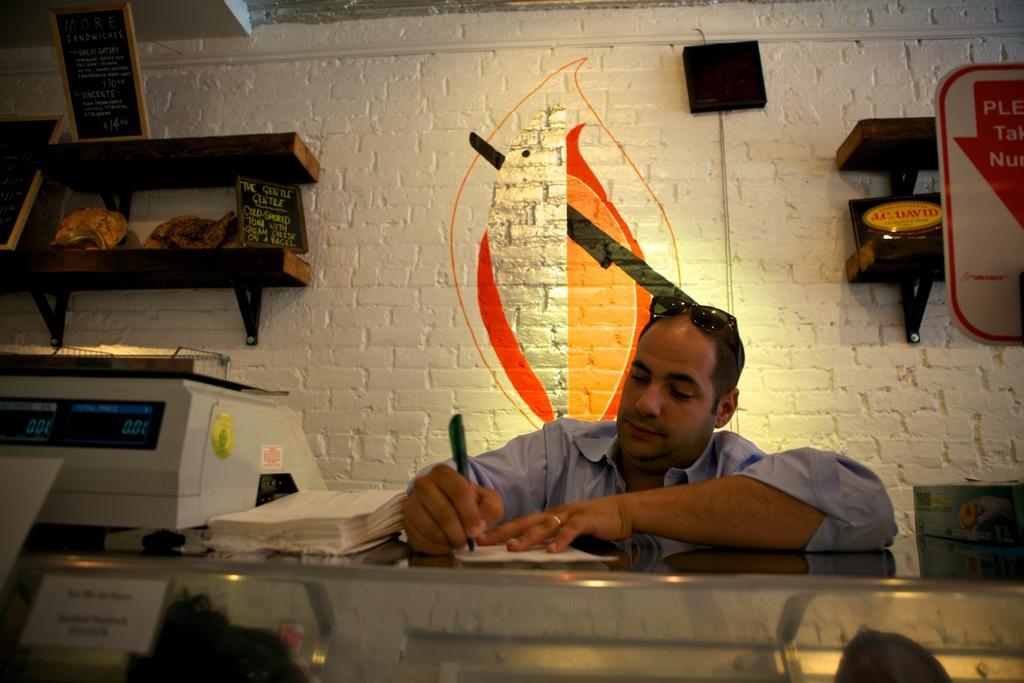Describe this image in one or two sentences. In this image I can see a person wearing blue colored dress is holding a pen in his hand. I can see the glass object on which I can see an electronic device and few papers. In the background I can see the wall, a board to the left side of the image and few objects in the desks to the wall. 